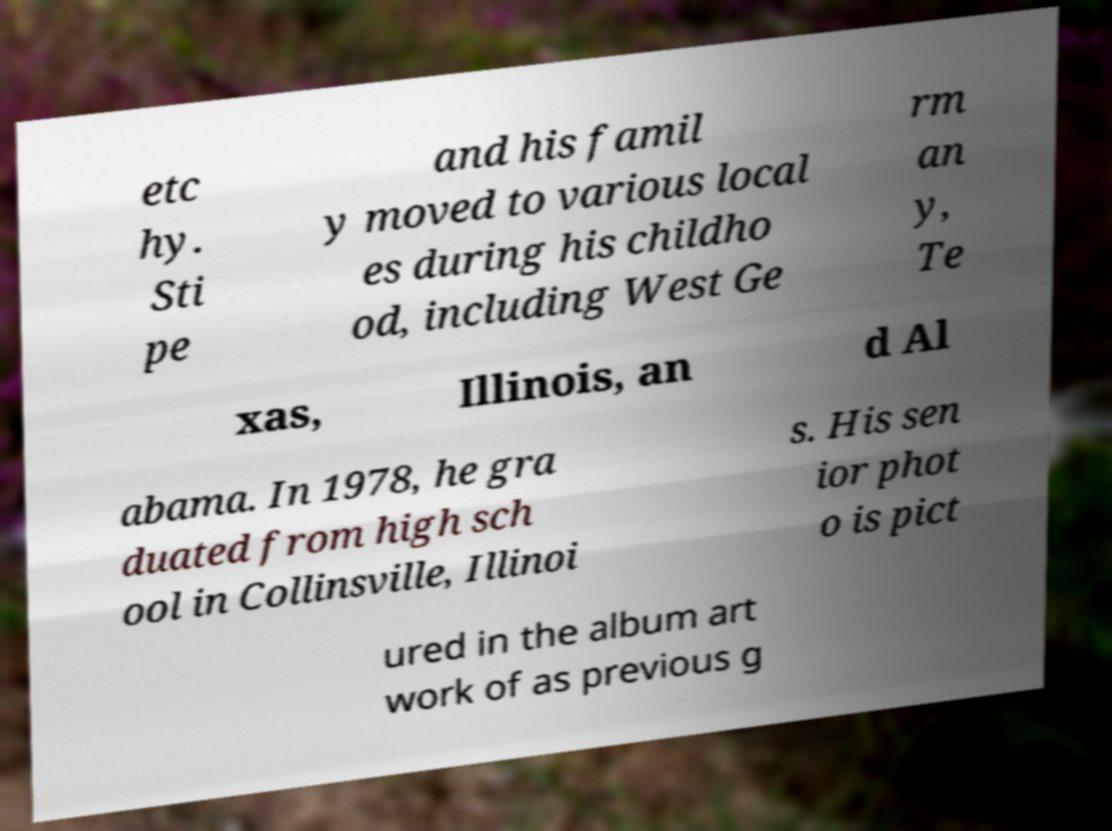Can you read and provide the text displayed in the image?This photo seems to have some interesting text. Can you extract and type it out for me? etc hy. Sti pe and his famil y moved to various local es during his childho od, including West Ge rm an y, Te xas, Illinois, an d Al abama. In 1978, he gra duated from high sch ool in Collinsville, Illinoi s. His sen ior phot o is pict ured in the album art work of as previous g 